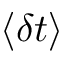<formula> <loc_0><loc_0><loc_500><loc_500>\langle \delta t \rangle</formula> 